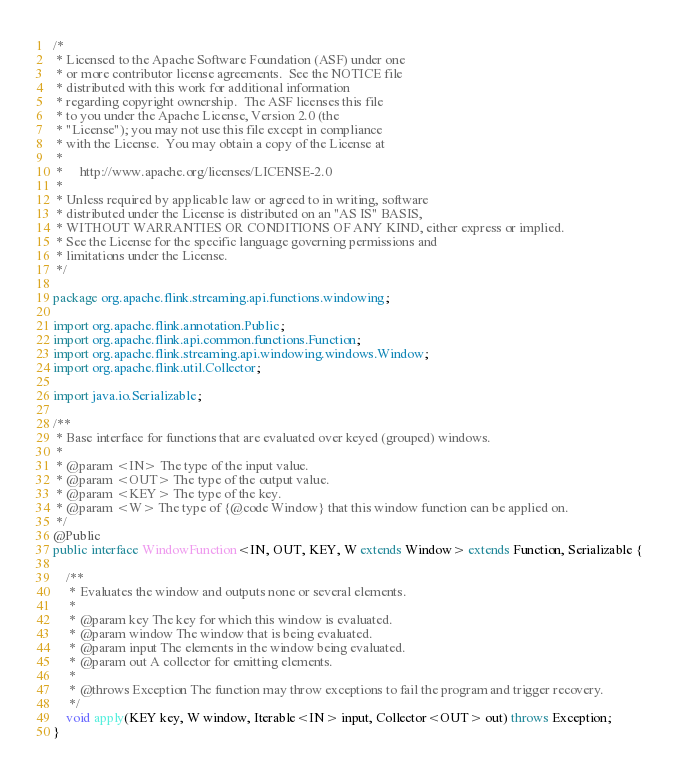<code> <loc_0><loc_0><loc_500><loc_500><_Java_>/*
 * Licensed to the Apache Software Foundation (ASF) under one
 * or more contributor license agreements.  See the NOTICE file
 * distributed with this work for additional information
 * regarding copyright ownership.  The ASF licenses this file
 * to you under the Apache License, Version 2.0 (the
 * "License"); you may not use this file except in compliance
 * with the License.  You may obtain a copy of the License at
 *
 *     http://www.apache.org/licenses/LICENSE-2.0
 *
 * Unless required by applicable law or agreed to in writing, software
 * distributed under the License is distributed on an "AS IS" BASIS,
 * WITHOUT WARRANTIES OR CONDITIONS OF ANY KIND, either express or implied.
 * See the License for the specific language governing permissions and
 * limitations under the License.
 */

package org.apache.flink.streaming.api.functions.windowing;

import org.apache.flink.annotation.Public;
import org.apache.flink.api.common.functions.Function;
import org.apache.flink.streaming.api.windowing.windows.Window;
import org.apache.flink.util.Collector;

import java.io.Serializable;

/**
 * Base interface for functions that are evaluated over keyed (grouped) windows.
 *
 * @param <IN> The type of the input value.
 * @param <OUT> The type of the output value.
 * @param <KEY> The type of the key.
 * @param <W> The type of {@code Window} that this window function can be applied on.
 */
@Public
public interface WindowFunction<IN, OUT, KEY, W extends Window> extends Function, Serializable {

	/**
	 * Evaluates the window and outputs none or several elements.
	 *
	 * @param key The key for which this window is evaluated.
	 * @param window The window that is being evaluated.
	 * @param input The elements in the window being evaluated.
	 * @param out A collector for emitting elements.
	 *
	 * @throws Exception The function may throw exceptions to fail the program and trigger recovery.
	 */
	void apply(KEY key, W window, Iterable<IN> input, Collector<OUT> out) throws Exception;
}
</code> 